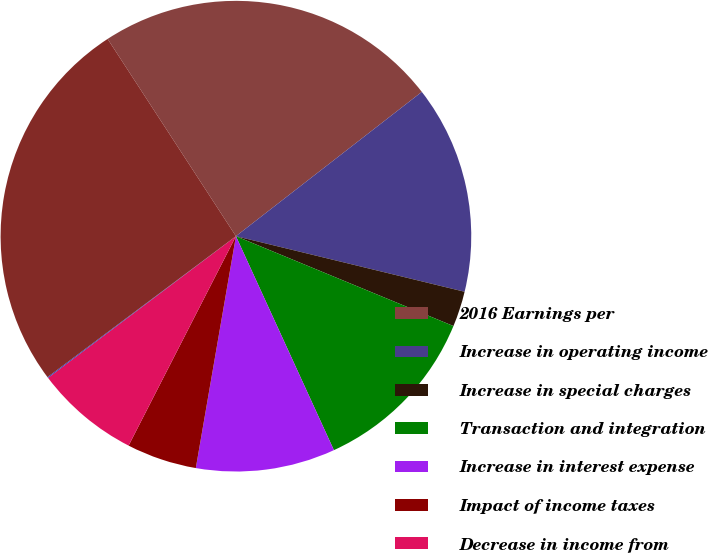Convert chart. <chart><loc_0><loc_0><loc_500><loc_500><pie_chart><fcel>2016 Earnings per<fcel>Increase in operating income<fcel>Increase in special charges<fcel>Transaction and integration<fcel>Increase in interest expense<fcel>Impact of income taxes<fcel>Decrease in income from<fcel>Impact of higher shares<fcel>2017 Earnings per<nl><fcel>23.67%<fcel>14.3%<fcel>2.44%<fcel>11.93%<fcel>9.56%<fcel>4.81%<fcel>7.18%<fcel>0.06%<fcel>26.04%<nl></chart> 